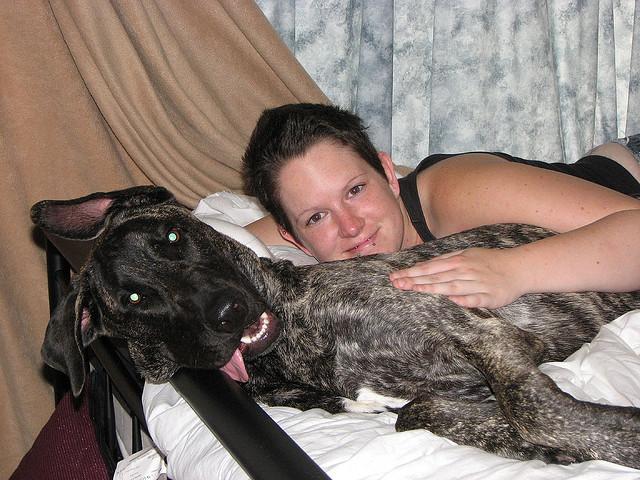Is this a small dog?
Write a very short answer. No. Is the woman happy?
Write a very short answer. Yes. Are the dog's teeth visible?
Quick response, please. Yes. 